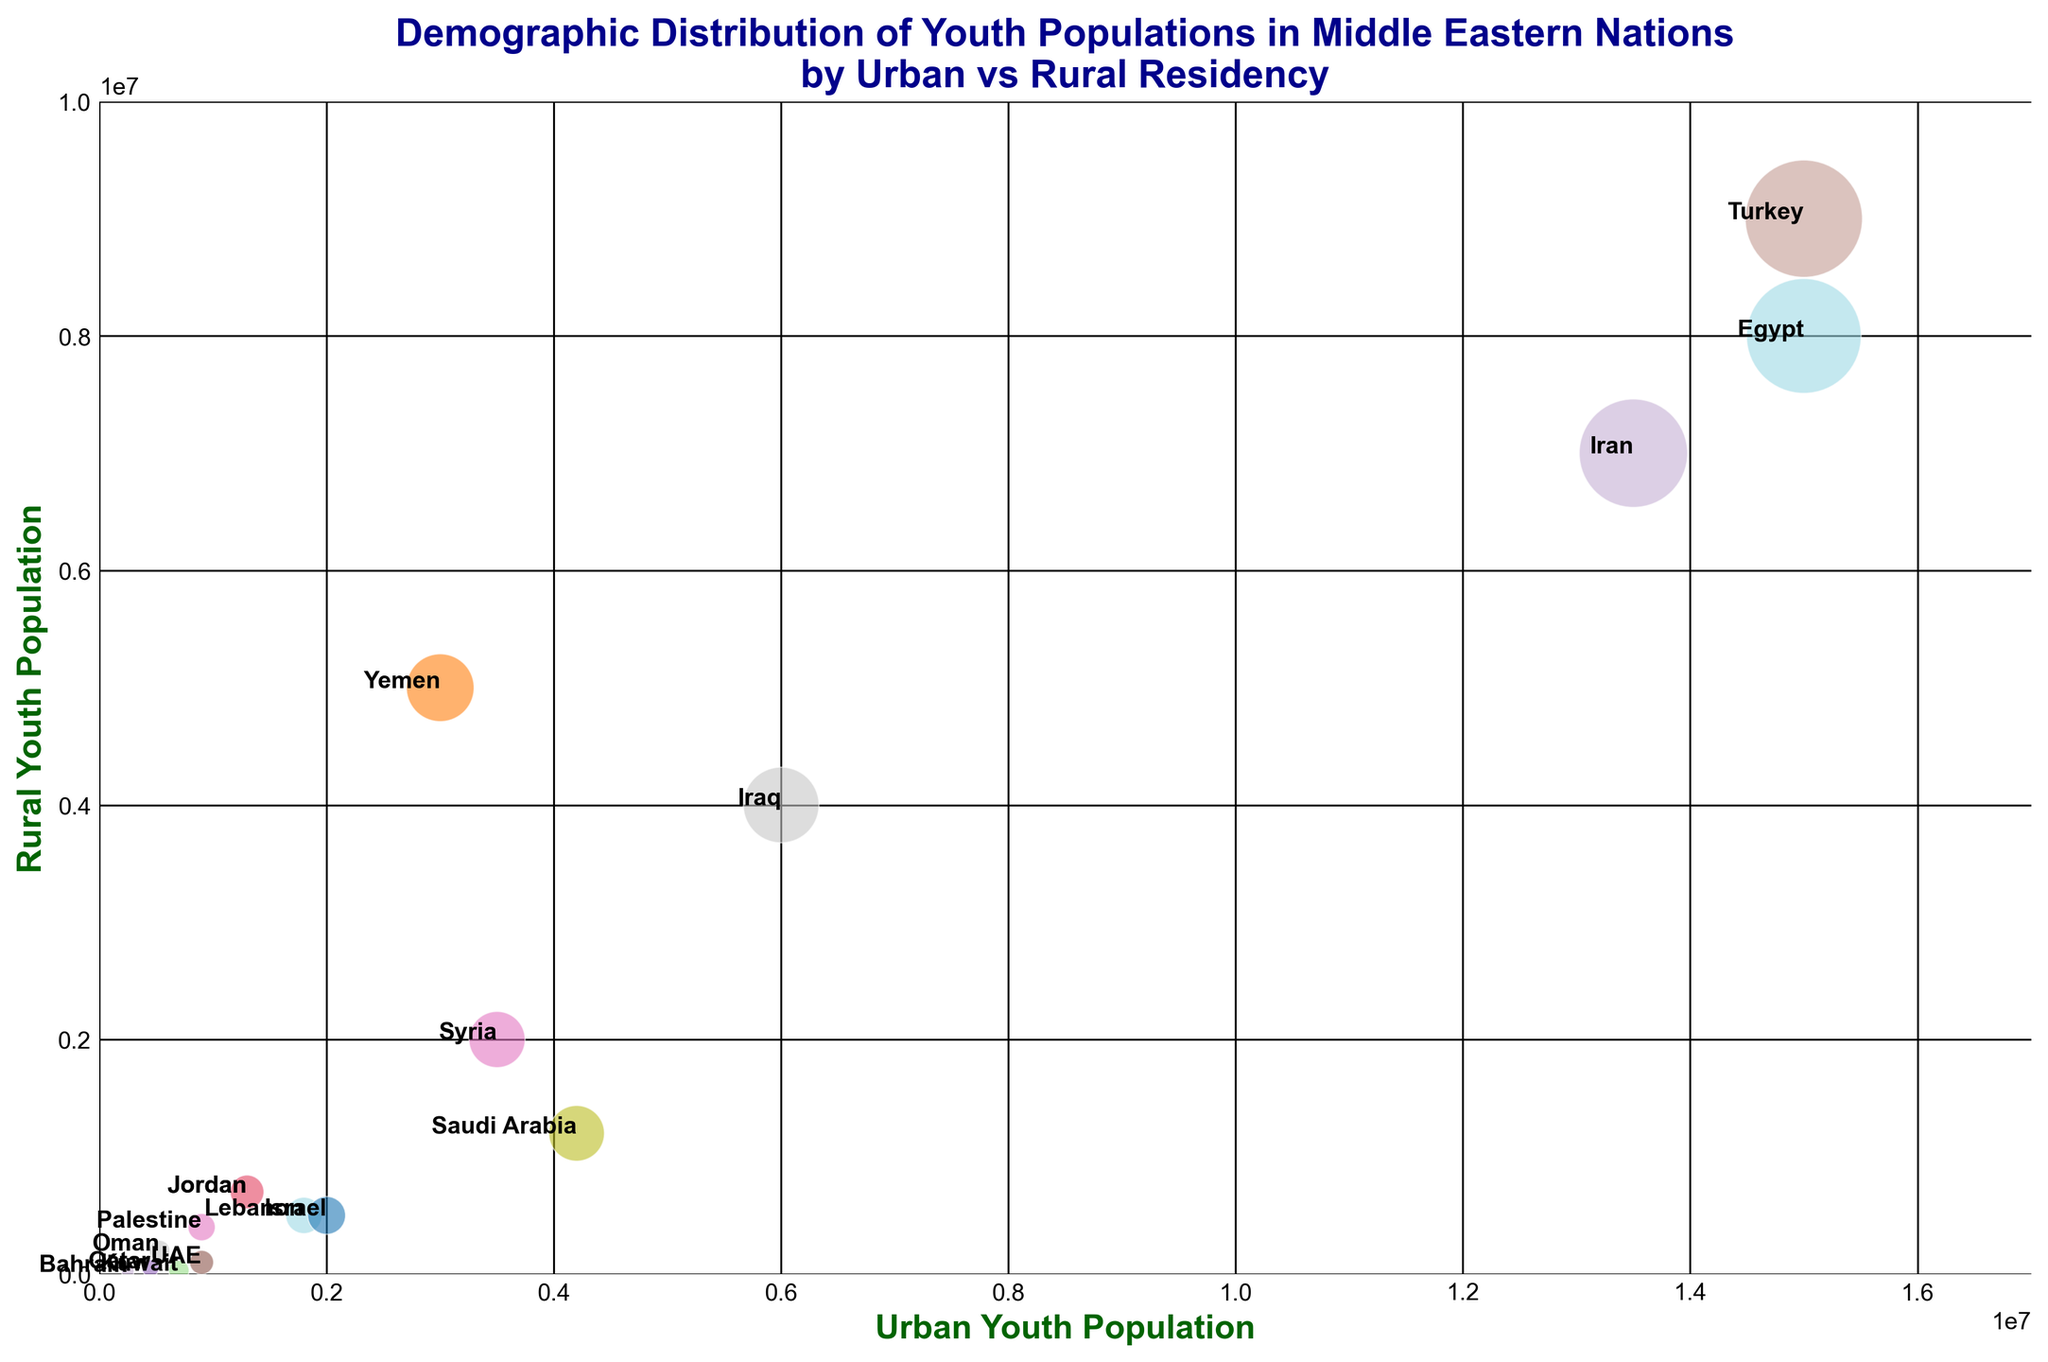What is the country with the highest urban youth population? From the visual cues in the bubble chart, the bubble representing Turkey is positioned the farthest right on the x-axis, which indicates the urban youth population. Hence, Turkey has the highest urban youth population.
Answer: Turkey Which country has the highest rural youth population? Observing the bubbles' positions along the y-axis, we can see that the bubble for Turkey is positioned the highest, which indicates that Turkey has the highest rural youth population.
Answer: Turkey What is the size of the youth population in Israel? By looking at the relative sizes of the bubbles, we locate Israel's bubble and observe its size, which indicates a youth population of 2,500,000 as labeled in the chart.
Answer: 2,500,000 Which country has a higher rural youth population, Iran or Saudi Arabia? The bubble for Iran is positioned higher on the y-axis compared to the bubble for Saudi Arabia, indicating that Iran has a higher rural youth population.
Answer: Iran Comparing Egypt and Turkey, which country has a larger rural youth population and by how much? Turkey's bubble is positioned higher than Egypt's on the y-axis. The rural youth population for Turkey is 9,000,000, while Egypt's is 8,000,000. The difference is 9,000,000 - 8,000,000 = 1,000,000.
Answer: Turkey by 1,000,000 Which country has a more balanced distribution between urban and rural youth populations, Oman or Yemen? The bubble for Oman is closer to an equal distribution along both the x-axis (Urban: 530,000) and y-axis (Rural: 200,000). Yemen's bubble is further skewed towards rural youth (Urban: 3,000,000, Rural: 5,000,000). Hence, Oman has a more balanced distribution.
Answer: Oman How does the total youth population of Bahrain compare to that of Lebanon? We compare the sizes of the bubbles. Lebanon’s bubble is larger than that of Bahrain, indicating that Lebanon has a greater total youth population. Lebanon has 2,300,000 youth, whereas Bahrain has 270,000.
Answer: Lebanon has a larger total youth population What is the difference in urban youth population between UAE and Qatar? The UAE's bubble is positioned further to the right on the x-axis (Urban: 900,000) compared to Qatar's bubble (Urban: 450,000). The difference is 900,000 - 450,000 = 450,000.
Answer: 450,000 Which country has the smallest total youth population? Looking at the smallest bubble in the chart, Bahrain has the smallest total youth population, indicating a population of 270,000 youth.
Answer: Bahrain What is the combined urban youth population of Egypt, Iran, and Turkey? By looking at the x-axis positions, we sum the urban youth populations of Egypt (15,000,000), Iran (13,500,000), and Turkey (15,000,000). The combined total is 15,000,000 + 13,500,000 + 15,000,000 = 43,500,000.
Answer: 43,500,000 